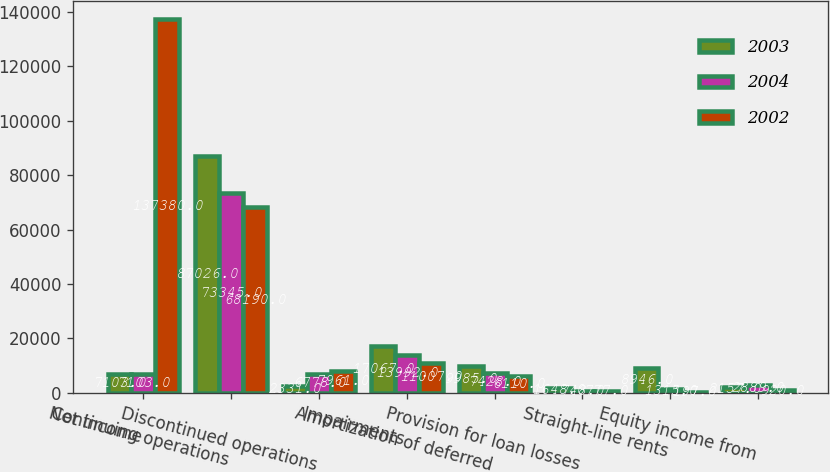Convert chart. <chart><loc_0><loc_0><loc_500><loc_500><stacked_bar_chart><ecel><fcel>Net income<fcel>Continuing operations<fcel>Discontinued operations<fcel>Impairments<fcel>Amortization of deferred<fcel>Provision for loan losses<fcel>Straight-line rents<fcel>Equity income from<nl><fcel>2003<fcel>7103<fcel>87026<fcel>2331<fcel>17067<fcel>9985<fcel>1648<fcel>8946<fcel>2157<nl><fcel>2004<fcel>7103<fcel>73345<fcel>6778<fcel>13992<fcel>7428<fcel>748<fcel>1315<fcel>2889<nl><fcel>2002<fcel>137380<fcel>68190<fcel>7961<fcel>11007<fcel>6110<fcel>777<fcel>197<fcel>920<nl></chart> 